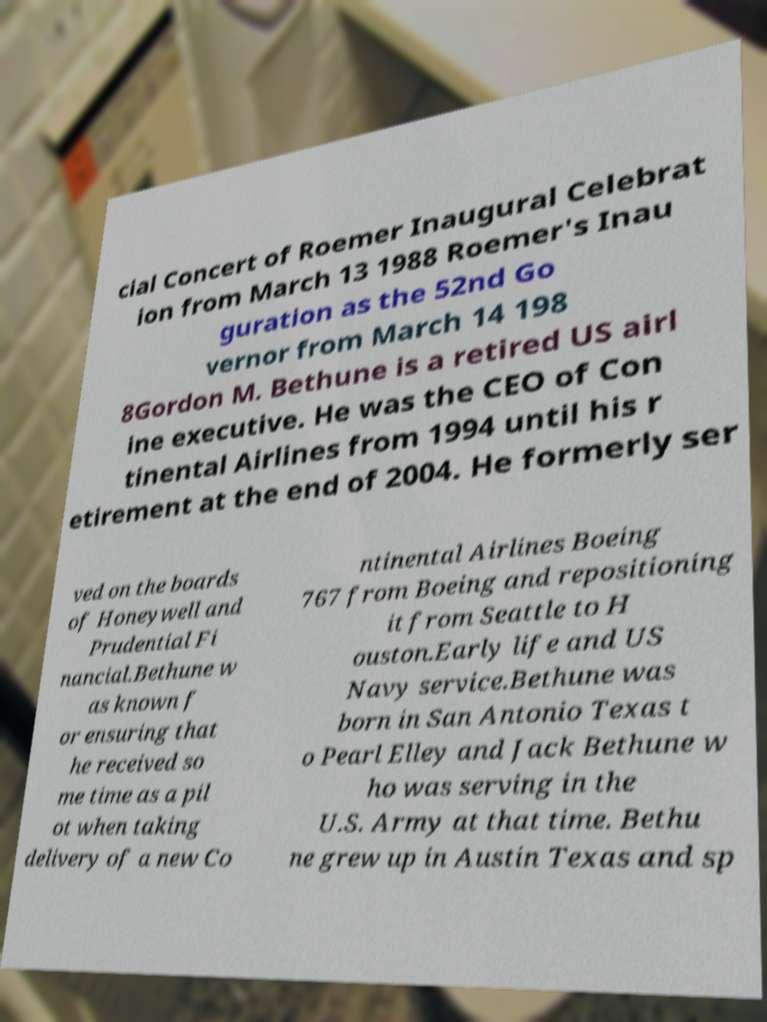There's text embedded in this image that I need extracted. Can you transcribe it verbatim? cial Concert of Roemer Inaugural Celebrat ion from March 13 1988 Roemer's Inau guration as the 52nd Go vernor from March 14 198 8Gordon M. Bethune is a retired US airl ine executive. He was the CEO of Con tinental Airlines from 1994 until his r etirement at the end of 2004. He formerly ser ved on the boards of Honeywell and Prudential Fi nancial.Bethune w as known f or ensuring that he received so me time as a pil ot when taking delivery of a new Co ntinental Airlines Boeing 767 from Boeing and repositioning it from Seattle to H ouston.Early life and US Navy service.Bethune was born in San Antonio Texas t o Pearl Elley and Jack Bethune w ho was serving in the U.S. Army at that time. Bethu ne grew up in Austin Texas and sp 